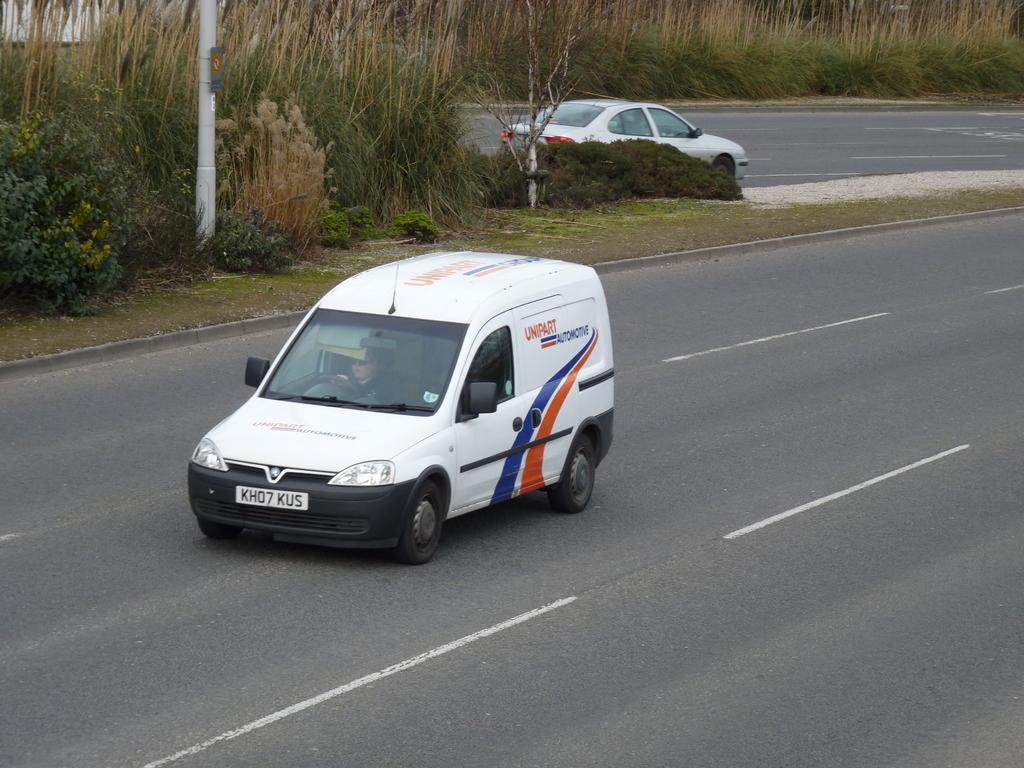Please provide a concise description of this image. In this image we can see two vehicles on the road and to the side there is a pavement and there are some plants and grass on it. There is a pole and we can see a tree. 